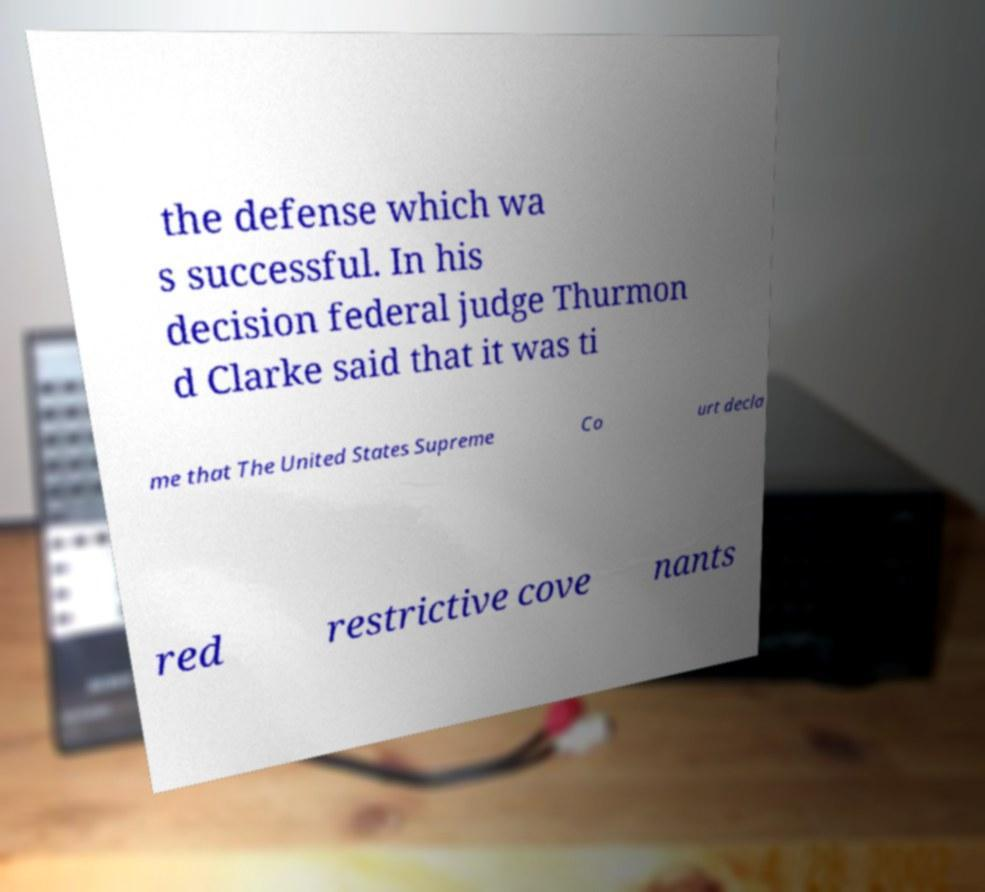Could you extract and type out the text from this image? the defense which wa s successful. In his decision federal judge Thurmon d Clarke said that it was ti me that The United States Supreme Co urt decla red restrictive cove nants 